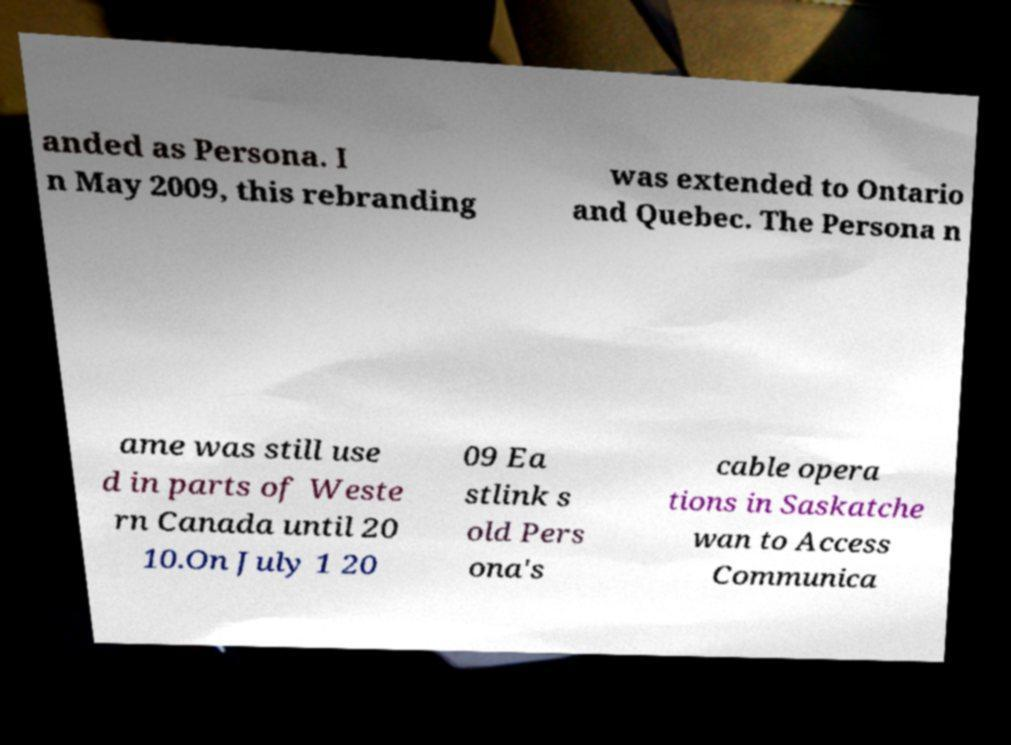There's text embedded in this image that I need extracted. Can you transcribe it verbatim? anded as Persona. I n May 2009, this rebranding was extended to Ontario and Quebec. The Persona n ame was still use d in parts of Weste rn Canada until 20 10.On July 1 20 09 Ea stlink s old Pers ona's cable opera tions in Saskatche wan to Access Communica 